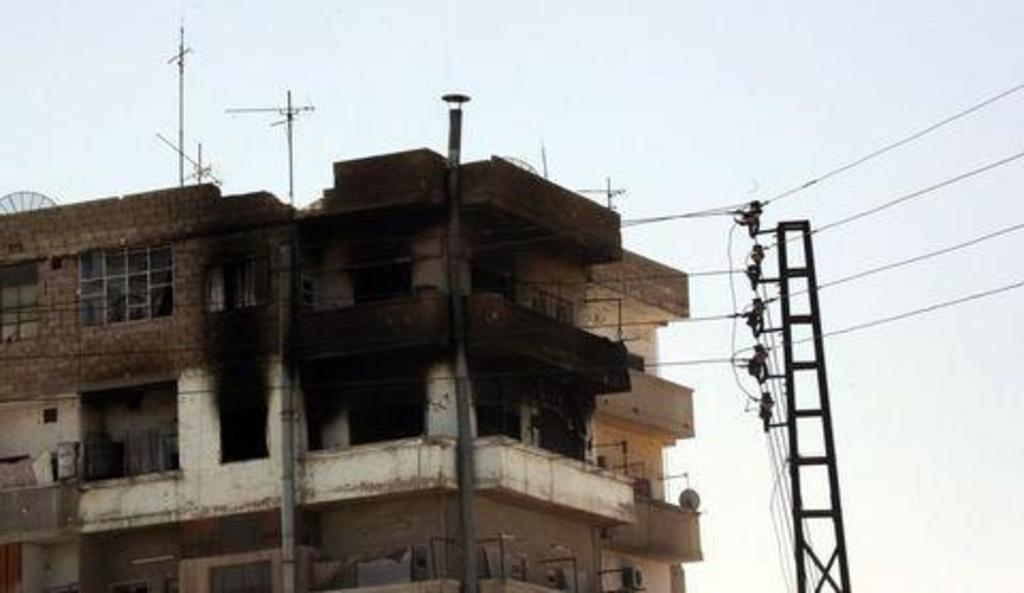What type of structure is visible in the image? There is a building in the image. What object is used for climbing in the image? There is a ladder in the image. What are the electrical poles connected to in the image? The electrical poles have wires in the image. What part of the natural environment is visible in the image? The sky is visible in the image. How many masses can be seen in the image? There is no mention of a mass in the image; it features a building, a ladder, electrical poles with wires, and the sky. What type of pail is used to collect water in the image? There is no pail present in the image. 